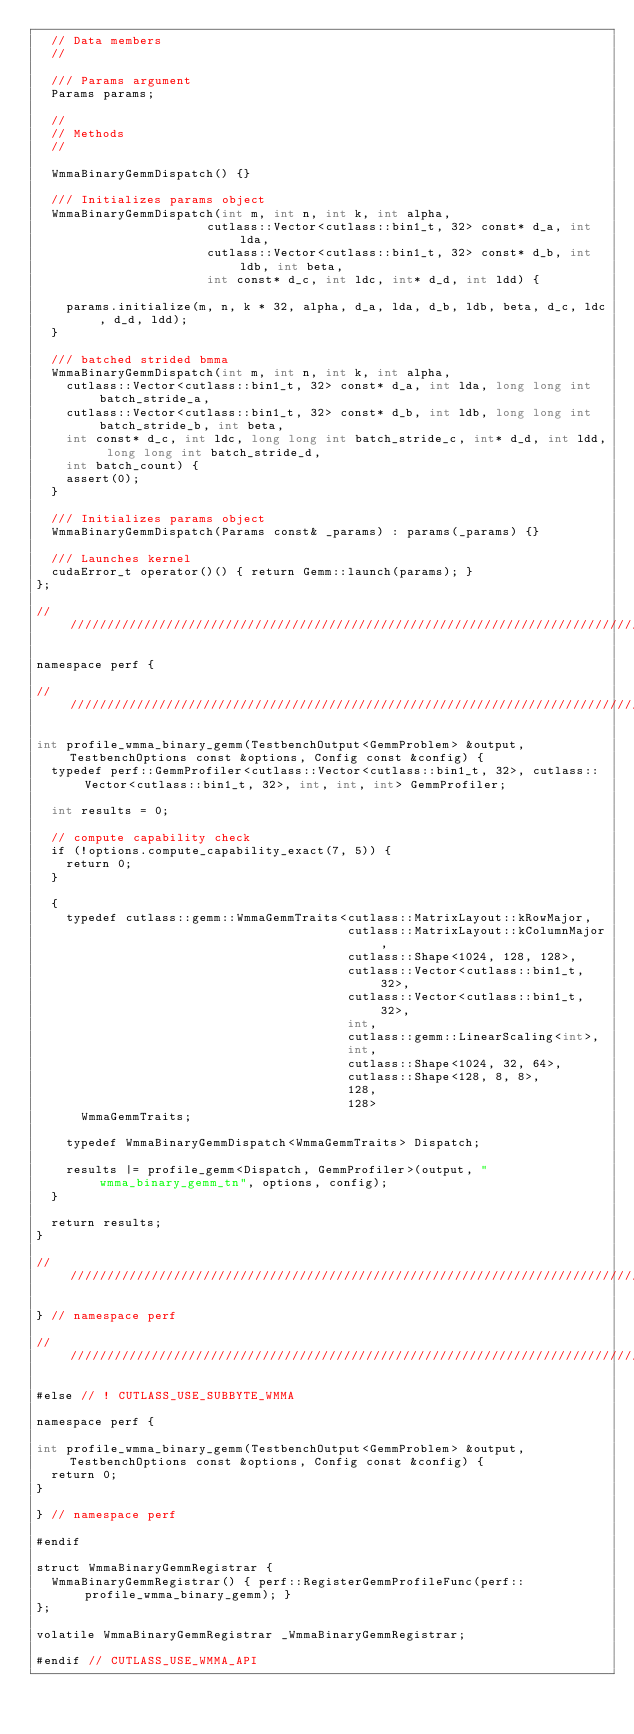<code> <loc_0><loc_0><loc_500><loc_500><_Cuda_>  // Data members
  //

  /// Params argument
  Params params;

  //
  // Methods
  //

  WmmaBinaryGemmDispatch() {}

  /// Initializes params object
  WmmaBinaryGemmDispatch(int m, int n, int k, int alpha,
                       cutlass::Vector<cutlass::bin1_t, 32> const* d_a, int lda,
                       cutlass::Vector<cutlass::bin1_t, 32> const* d_b, int ldb, int beta,
                       int const* d_c, int ldc, int* d_d, int ldd) {

    params.initialize(m, n, k * 32, alpha, d_a, lda, d_b, ldb, beta, d_c, ldc, d_d, ldd);
  }

  /// batched strided bmma
  WmmaBinaryGemmDispatch(int m, int n, int k, int alpha,
    cutlass::Vector<cutlass::bin1_t, 32> const* d_a, int lda, long long int batch_stride_a, 
    cutlass::Vector<cutlass::bin1_t, 32> const* d_b, int ldb, long long int batch_stride_b, int beta,
    int const* d_c, int ldc, long long int batch_stride_c, int* d_d, int ldd, long long int batch_stride_d,
    int batch_count) {
    assert(0);
  }

  /// Initializes params object
  WmmaBinaryGemmDispatch(Params const& _params) : params(_params) {}

  /// Launches kernel
  cudaError_t operator()() { return Gemm::launch(params); }
};

////////////////////////////////////////////////////////////////////////////////////////////////////

namespace perf {

////////////////////////////////////////////////////////////////////////////////////////////////////

int profile_wmma_binary_gemm(TestbenchOutput<GemmProblem> &output, TestbenchOptions const &options, Config const &config) {
  typedef perf::GemmProfiler<cutlass::Vector<cutlass::bin1_t, 32>, cutlass::Vector<cutlass::bin1_t, 32>, int, int, int> GemmProfiler;

  int results = 0;

  // compute capability check
  if (!options.compute_capability_exact(7, 5)) {
    return 0;
  }

  {
    typedef cutlass::gemm::WmmaGemmTraits<cutlass::MatrixLayout::kRowMajor,
                                          cutlass::MatrixLayout::kColumnMajor,
                                          cutlass::Shape<1024, 128, 128>,
                                          cutlass::Vector<cutlass::bin1_t, 32>,
                                          cutlass::Vector<cutlass::bin1_t, 32>,
                                          int,
                                          cutlass::gemm::LinearScaling<int>,
                                          int,
                                          cutlass::Shape<1024, 32, 64>,
                                          cutlass::Shape<128, 8, 8>,
                                          128,
                                          128>
      WmmaGemmTraits;

    typedef WmmaBinaryGemmDispatch<WmmaGemmTraits> Dispatch;

    results |= profile_gemm<Dispatch, GemmProfiler>(output, "wmma_binary_gemm_tn", options, config);
  }

  return results;
}

////////////////////////////////////////////////////////////////////////////////////////////////////

} // namespace perf

////////////////////////////////////////////////////////////////////////////////////////////////////

#else // ! CUTLASS_USE_SUBBYTE_WMMA

namespace perf {

int profile_wmma_binary_gemm(TestbenchOutput<GemmProblem> &output, TestbenchOptions const &options, Config const &config) {
  return 0;
}

} // namespace perf

#endif

struct WmmaBinaryGemmRegistrar {
  WmmaBinaryGemmRegistrar() { perf::RegisterGemmProfileFunc(perf::profile_wmma_binary_gemm); }
};

volatile WmmaBinaryGemmRegistrar _WmmaBinaryGemmRegistrar;

#endif // CUTLASS_USE_WMMA_API
</code> 